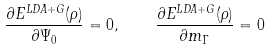Convert formula to latex. <formula><loc_0><loc_0><loc_500><loc_500>\frac { \partial { E ^ { L D A + G } ( \rho ) } } { \partial { \Psi _ { 0 } } } = 0 , \quad \frac { \partial { E ^ { L D A + G } ( \rho ) } } { \partial { m _ { \Gamma } } } = 0</formula> 